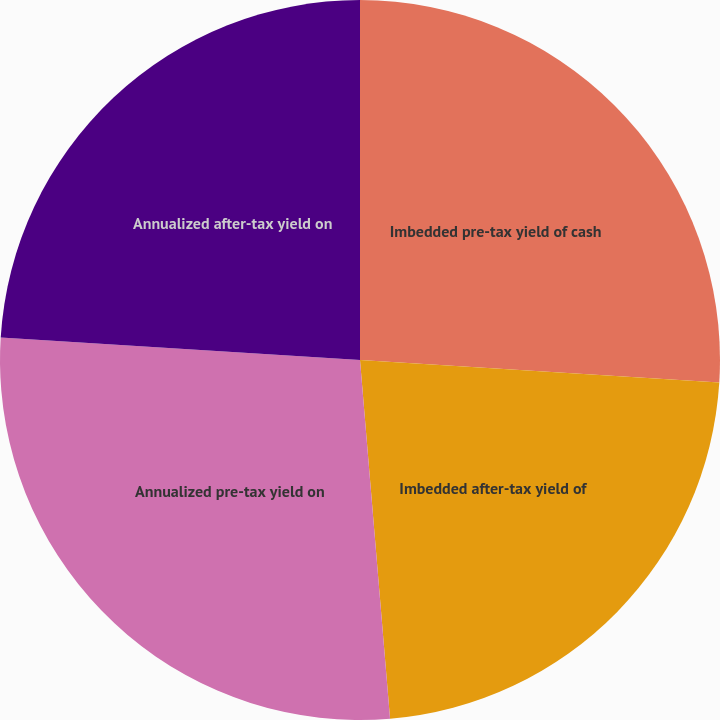Convert chart to OTSL. <chart><loc_0><loc_0><loc_500><loc_500><pie_chart><fcel>Imbedded pre-tax yield of cash<fcel>Imbedded after-tax yield of<fcel>Annualized pre-tax yield on<fcel>Annualized after-tax yield on<nl><fcel>26.0%<fcel>22.67%<fcel>27.33%<fcel>24.0%<nl></chart> 